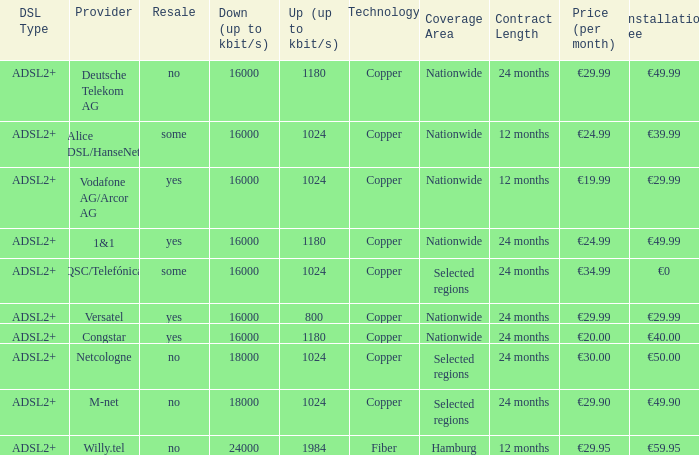How many providers are there where the resale category is yes and bandwith is up is 1024? 1.0. Write the full table. {'header': ['DSL Type', 'Provider', 'Resale', 'Down (up to kbit/s)', 'Up (up to kbit/s)', 'Technology', 'Coverage Area', 'Contract Length', 'Price (per month)', 'Installation Fee'], 'rows': [['ADSL2+', 'Deutsche Telekom AG', 'no', '16000', '1180', 'Copper', 'Nationwide', '24 months', '€29.99', '€49.99'], ['ADSL2+', 'Alice DSL/HanseNet', 'some', '16000', '1024', 'Copper', 'Nationwide', '12 months', '€24.99', '€39.99'], ['ADSL2+', 'Vodafone AG/Arcor AG', 'yes', '16000', '1024', 'Copper', 'Nationwide', '12 months', '€19.99', '€29.99'], ['ADSL2+', '1&1', 'yes', '16000', '1180', 'Copper', 'Nationwide', '24 months', '€24.99', '€49.99'], ['ADSL2+', 'QSC/Telefónica', 'some', '16000', '1024', 'Copper', 'Selected regions', '24 months', '€34.99', '€0'], ['ADSL2+', 'Versatel', 'yes', '16000', '800', 'Copper', 'Nationwide', '24 months', '€29.99', '€29.99'], ['ADSL2+', 'Congstar', 'yes', '16000', '1180', 'Copper', 'Nationwide', '24 months', '€20.00', '€40.00'], ['ADSL2+', 'Netcologne', 'no', '18000', '1024', 'Copper', 'Selected regions', '24 months', '€30.00', '€50.00'], ['ADSL2+', 'M-net', 'no', '18000', '1024', 'Copper', 'Selected regions', '24 months', '€29.90', '€49.90'], ['ADSL2+', 'Willy.tel', 'no', '24000', '1984', 'Fiber', 'Hamburg', '12 months', '€29.95', '€59.95']]} 